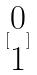Convert formula to latex. <formula><loc_0><loc_0><loc_500><loc_500>[ \begin{matrix} 0 \\ 1 \end{matrix} ]</formula> 